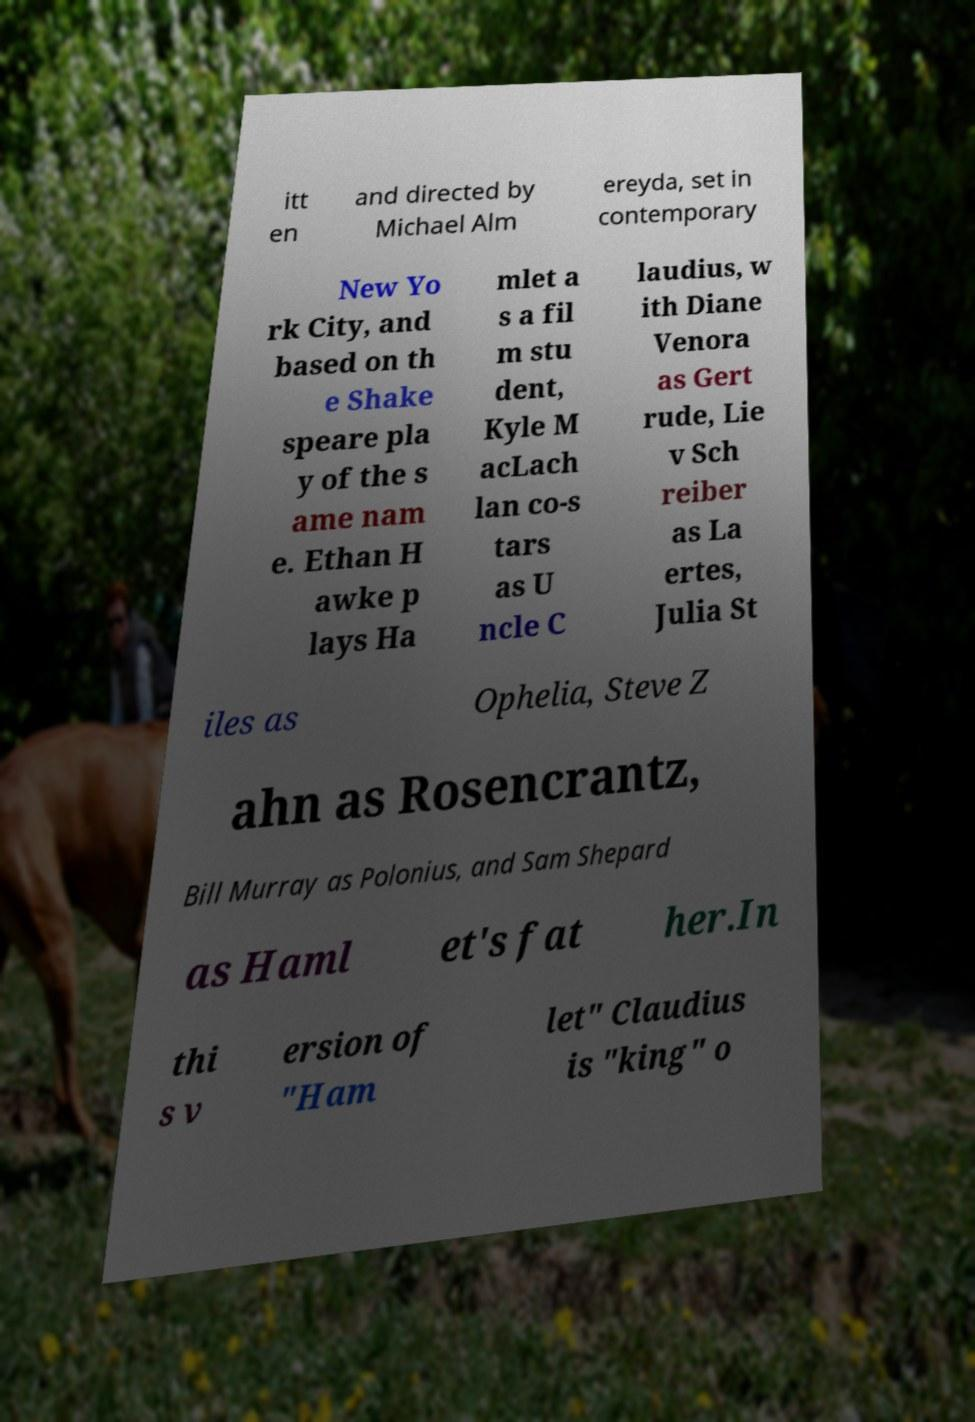Please read and relay the text visible in this image. What does it say? itt en and directed by Michael Alm ereyda, set in contemporary New Yo rk City, and based on th e Shake speare pla y of the s ame nam e. Ethan H awke p lays Ha mlet a s a fil m stu dent, Kyle M acLach lan co-s tars as U ncle C laudius, w ith Diane Venora as Gert rude, Lie v Sch reiber as La ertes, Julia St iles as Ophelia, Steve Z ahn as Rosencrantz, Bill Murray as Polonius, and Sam Shepard as Haml et's fat her.In thi s v ersion of "Ham let" Claudius is "king" o 